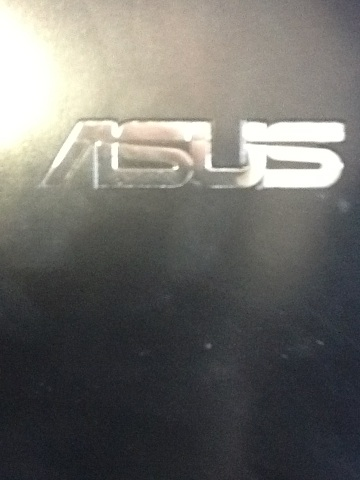Can you tell me about the company associated with the logo in the image? The logo in the image belongs to Asus, a multinational computer and phone hardware and electronics company headquartered in Taiwan. They are known for their high-quality laptops, desktops, motherboards, and other electronics. Asus products are widely used both by consumers and in professional settings. 